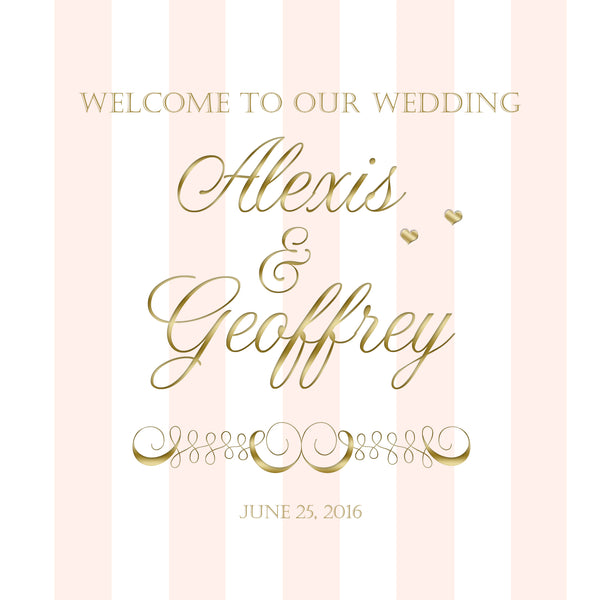Imagine what the dining setup might look like if it carries the sharegpt4v/same pink and gold theme. For a dining setup following the pink and gold theme, imagine long tables draped with blush pink linens and gold-rimmed chargers. Each place setting would be complemented with elegant gold cutlery and pink-tinted glassware. The centerpieces would feature lush arrangements of blush flowers with gold accents, perhaps placed in gold vases or candelabras. Crystal chandeliers might hang overhead, casting a warm glow over the elegantly set tables, and pink satin napkins with gold napkin rings would complete the luxurious look. 